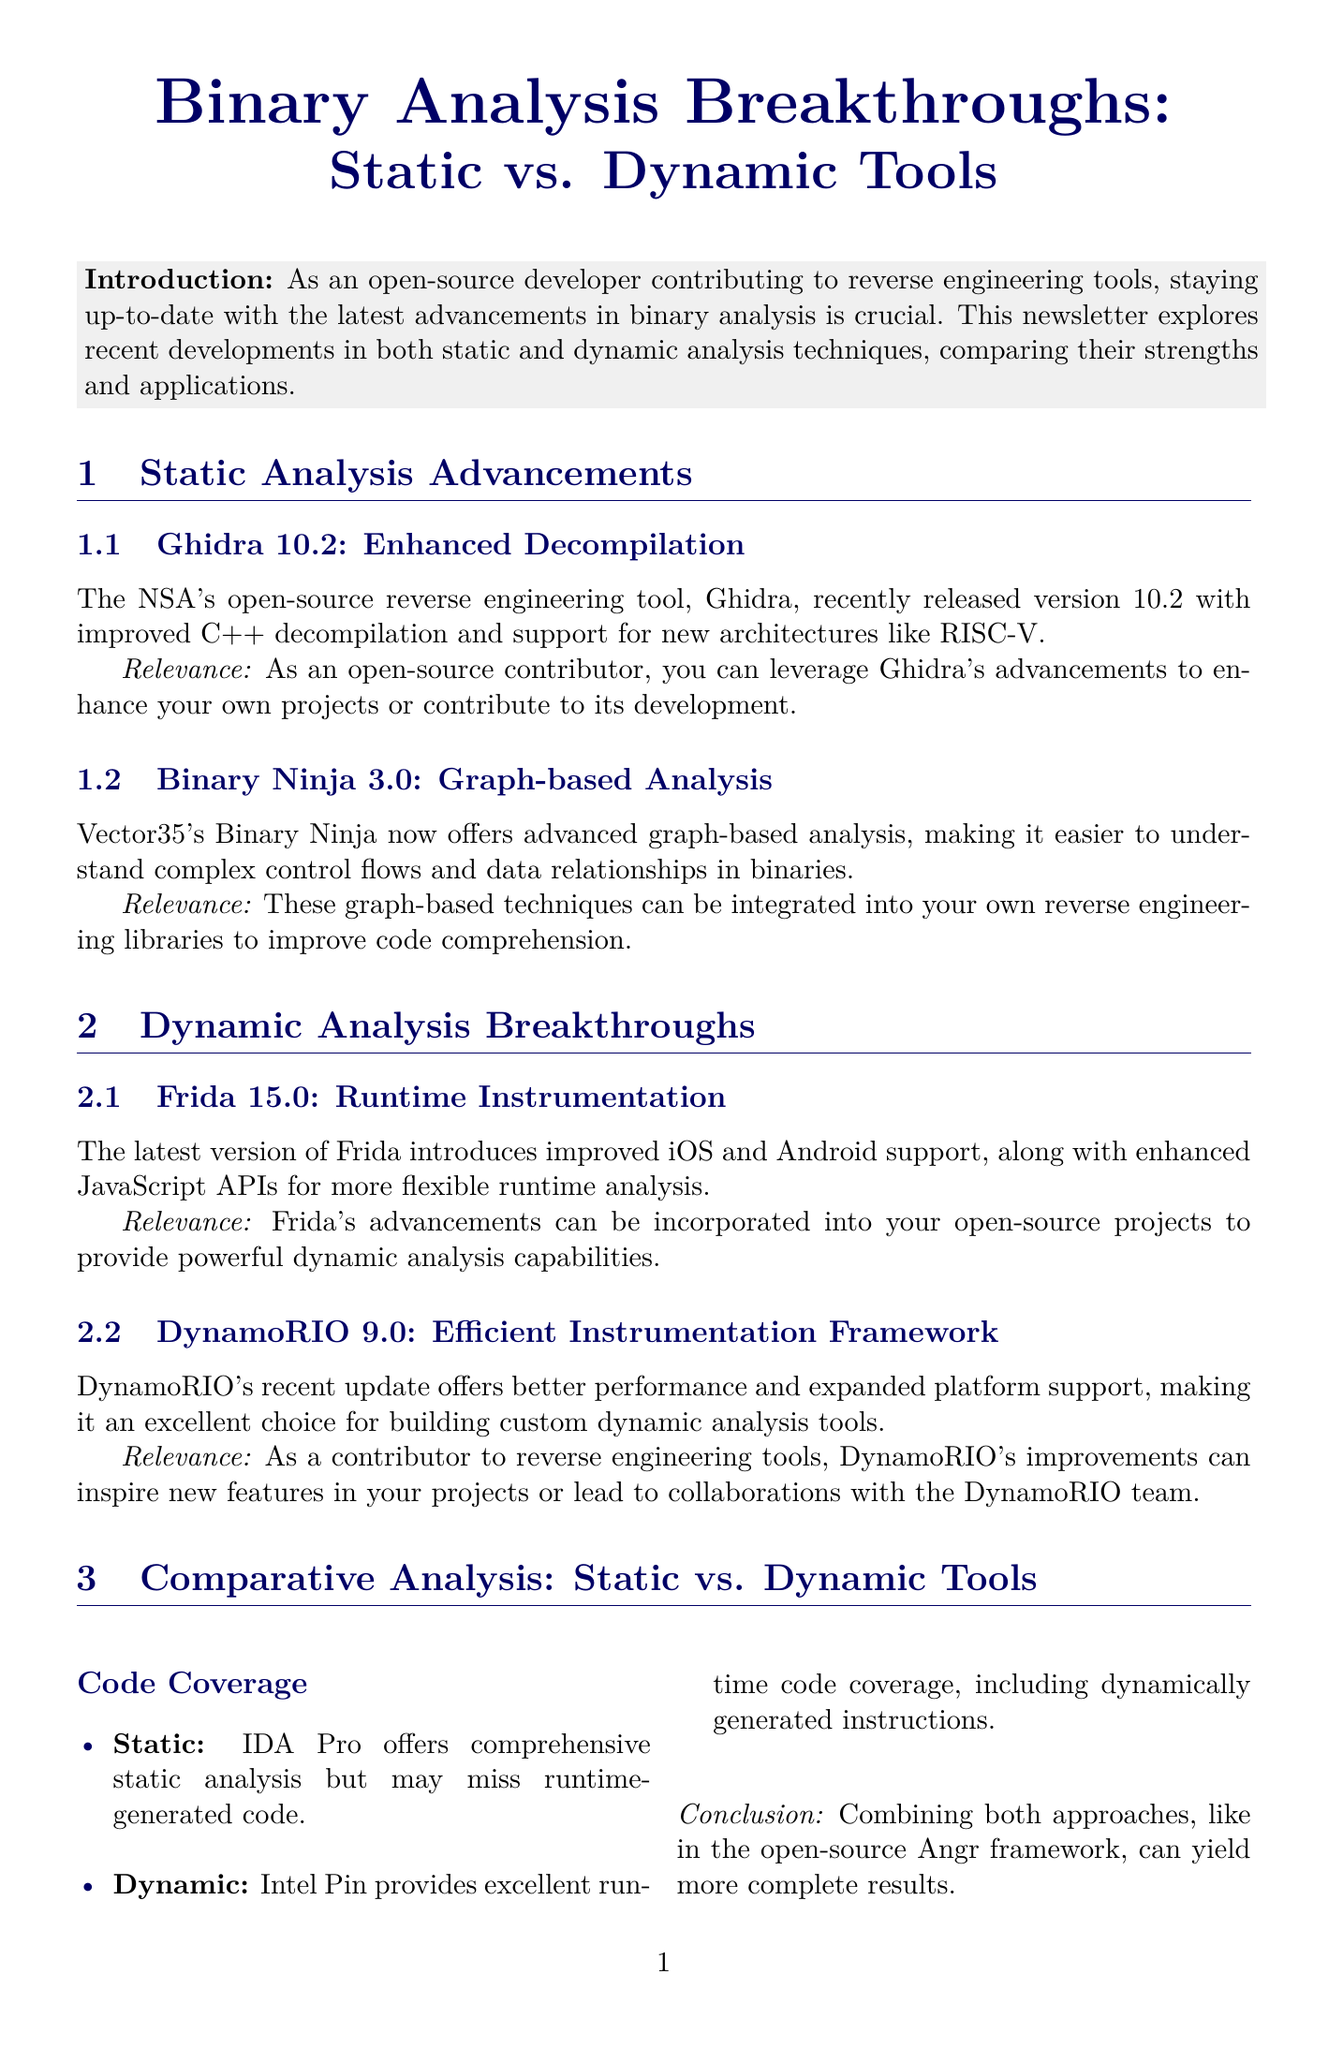What is the title of the newsletter? The title of the newsletter is mentioned at the beginning, summarizing its focus on binary analysis.
Answer: Binary Analysis Breakthroughs: Static vs. Dynamic Tools What version of Ghidra was recently released? The document specifies the version that includes the latest features of Ghidra.
Answer: 10.2 What improved feature is highlighted in Binary Ninja 3.0? The document discusses the key advancement in Binary Ninja regarding analysis capabilities.
Answer: Graph-based analysis Which framework provides better performance for dynamic analysis tools? The newsletter indicates a specific framework that excels in performance improvements for such tools.
Answer: DynamoRIO What is the main purpose of YARA rules in malware analysis? The document identifies the primary function of YARA rules in the context of analyzing malware threats.
Answer: Identifying known malware patterns Which dynamic tool's heavy instrumentation can slow down execution? The document mentions a dynamic tool that impacts performance due to its design.
Answer: Valgrind What is the conclusion regarding combining static and dynamic tools? The conclusion summarizes the benefits of using both analysis types together.
Answer: More complete results What is the call to action for open-source developers? The document suggests a specific next step for developers interested in the content.
Answer: Explore these tools, contribute to their development, or incorporate their techniques into your own open-source projects 